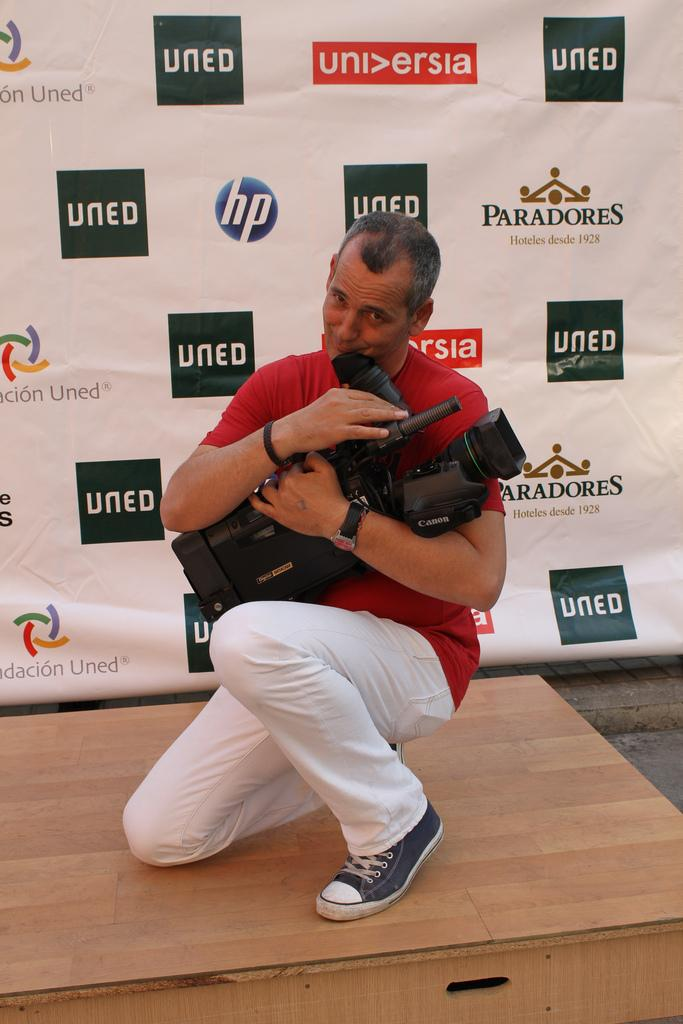<image>
Share a concise interpretation of the image provided. A man holds a camera in front of a board with black boxes with contain the letters UNED. 